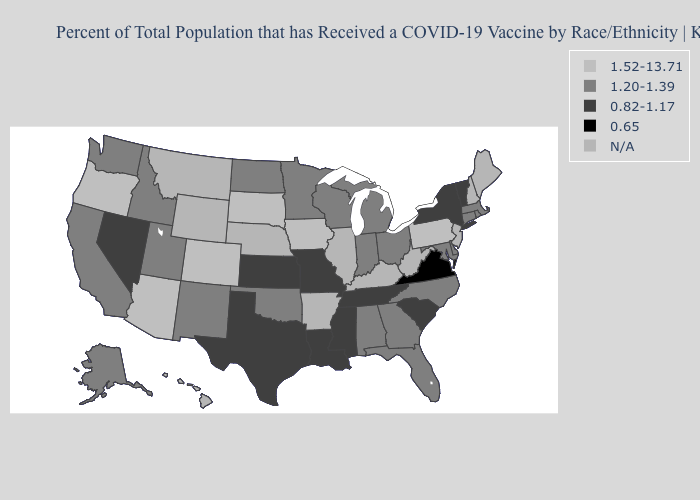What is the value of Louisiana?
Answer briefly. 0.82-1.17. What is the lowest value in states that border Massachusetts?
Quick response, please. 0.82-1.17. Does Indiana have the highest value in the USA?
Be succinct. No. Does the map have missing data?
Be succinct. Yes. Does Virginia have the lowest value in the USA?
Concise answer only. Yes. What is the value of Massachusetts?
Write a very short answer. 1.20-1.39. What is the value of Oklahoma?
Concise answer only. 1.20-1.39. Name the states that have a value in the range 0.65?
Quick response, please. Virginia. Name the states that have a value in the range N/A?
Write a very short answer. Arkansas, Hawaii, Illinois, Kentucky, Maine, Montana, Nebraska, New Hampshire, New Jersey, West Virginia, Wyoming. What is the value of Michigan?
Write a very short answer. 1.20-1.39. Name the states that have a value in the range 0.82-1.17?
Quick response, please. Kansas, Louisiana, Mississippi, Missouri, Nevada, New York, South Carolina, Tennessee, Texas, Vermont. What is the value of Virginia?
Answer briefly. 0.65. Does Missouri have the lowest value in the MidWest?
Give a very brief answer. Yes. What is the lowest value in states that border Oklahoma?
Be succinct. 0.82-1.17. Does Idaho have the highest value in the West?
Short answer required. No. 